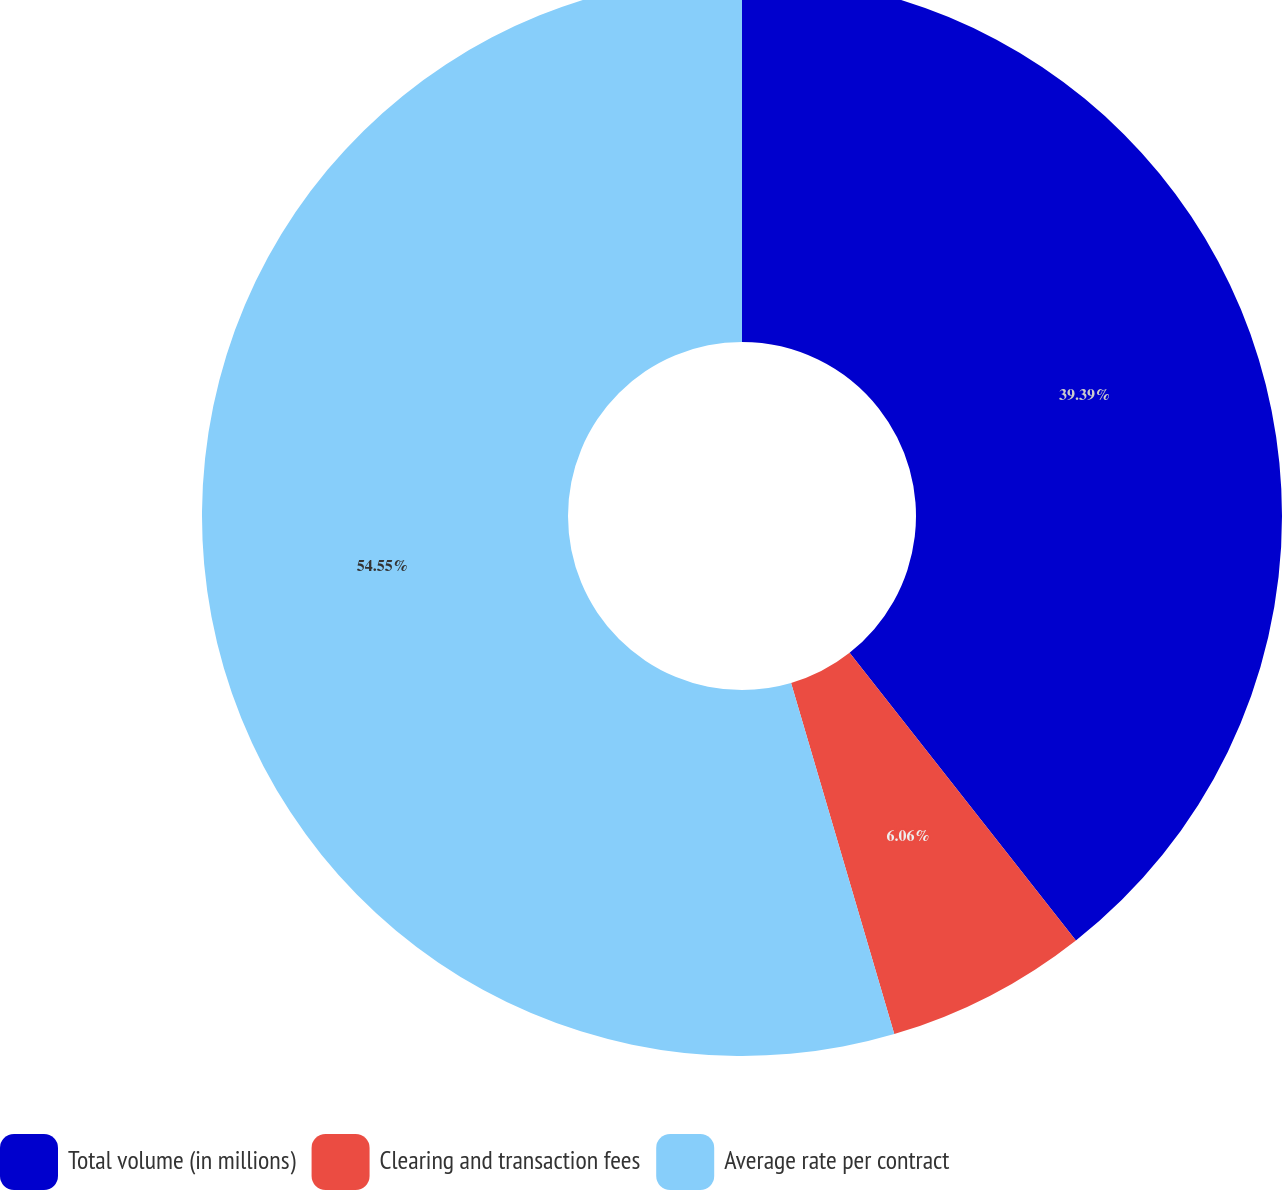Convert chart to OTSL. <chart><loc_0><loc_0><loc_500><loc_500><pie_chart><fcel>Total volume (in millions)<fcel>Clearing and transaction fees<fcel>Average rate per contract<nl><fcel>39.39%<fcel>6.06%<fcel>54.55%<nl></chart> 